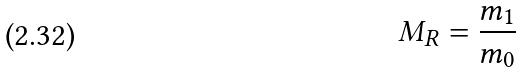<formula> <loc_0><loc_0><loc_500><loc_500>M _ { R } = \frac { m _ { 1 } } { m _ { 0 } }</formula> 